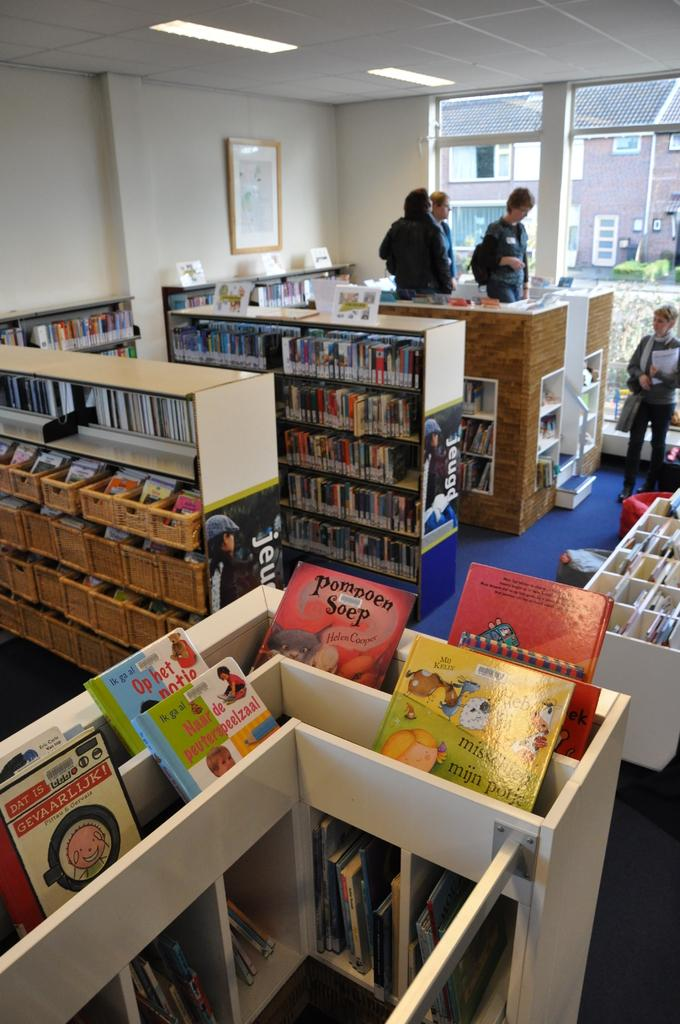<image>
Relay a brief, clear account of the picture shown. A bunch of books on display in a library including a red one titled Pompoen Soap. 